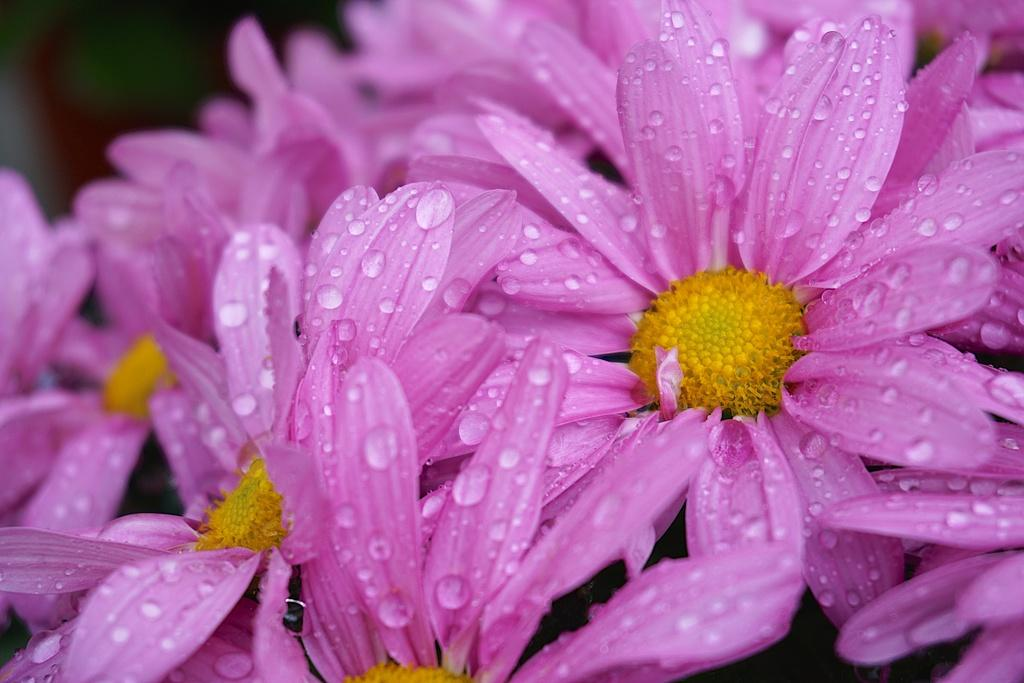What is present in the image? There are flowers in the image. What can be observed on the flowers? The flowers have water drops on them. Can you describe the background of the image? The background of the image is blurry. How many lizards can be seen climbing on the flowers in the image? There are no lizards present in the image; it only features flowers with water drops. 